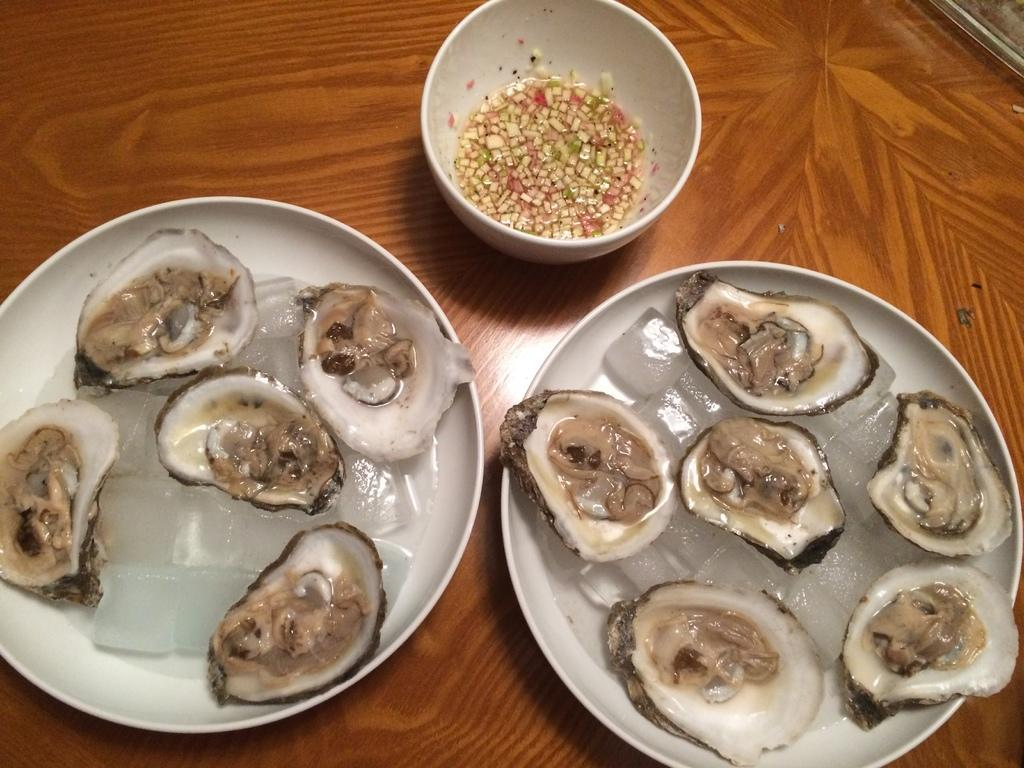What is on the plates in the image? There are food items on plates in the image. What is the surface beneath the plates made of? The plates are placed on a wooden surface. Can you describe the presence of ice in the image? Yes, there is ice visible in the image. How many slaves are depicted in the image? There are no slaves present in the image. What type of lock can be seen securing the food items in the image? There is no lock present in the image; the food items are on plates. 